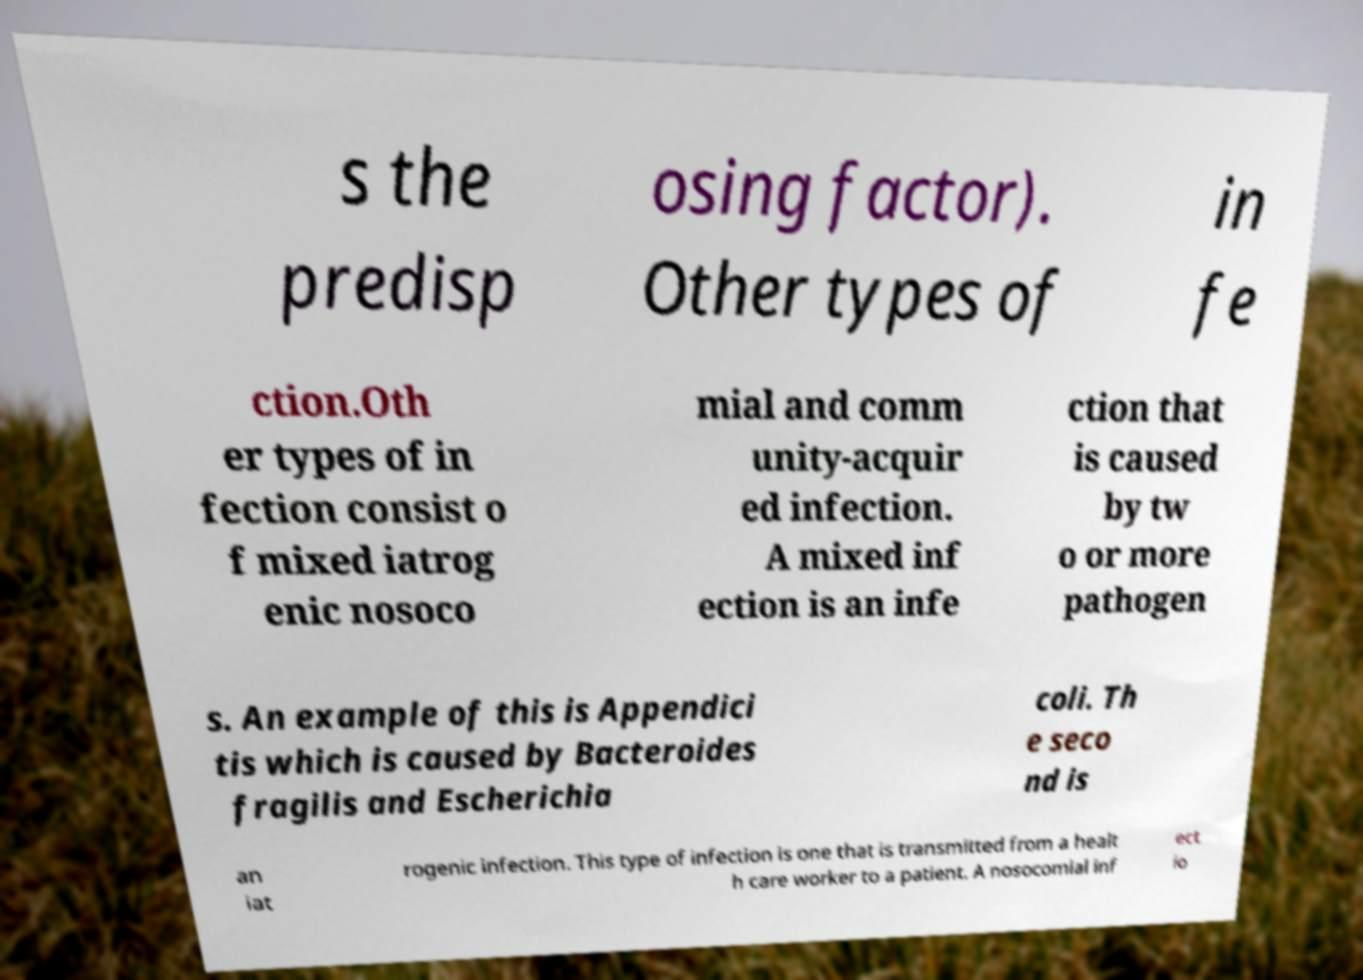Please identify and transcribe the text found in this image. s the predisp osing factor). Other types of in fe ction.Oth er types of in fection consist o f mixed iatrog enic nosoco mial and comm unity-acquir ed infection. A mixed inf ection is an infe ction that is caused by tw o or more pathogen s. An example of this is Appendici tis which is caused by Bacteroides fragilis and Escherichia coli. Th e seco nd is an iat rogenic infection. This type of infection is one that is transmitted from a healt h care worker to a patient. A nosocomial inf ect io 